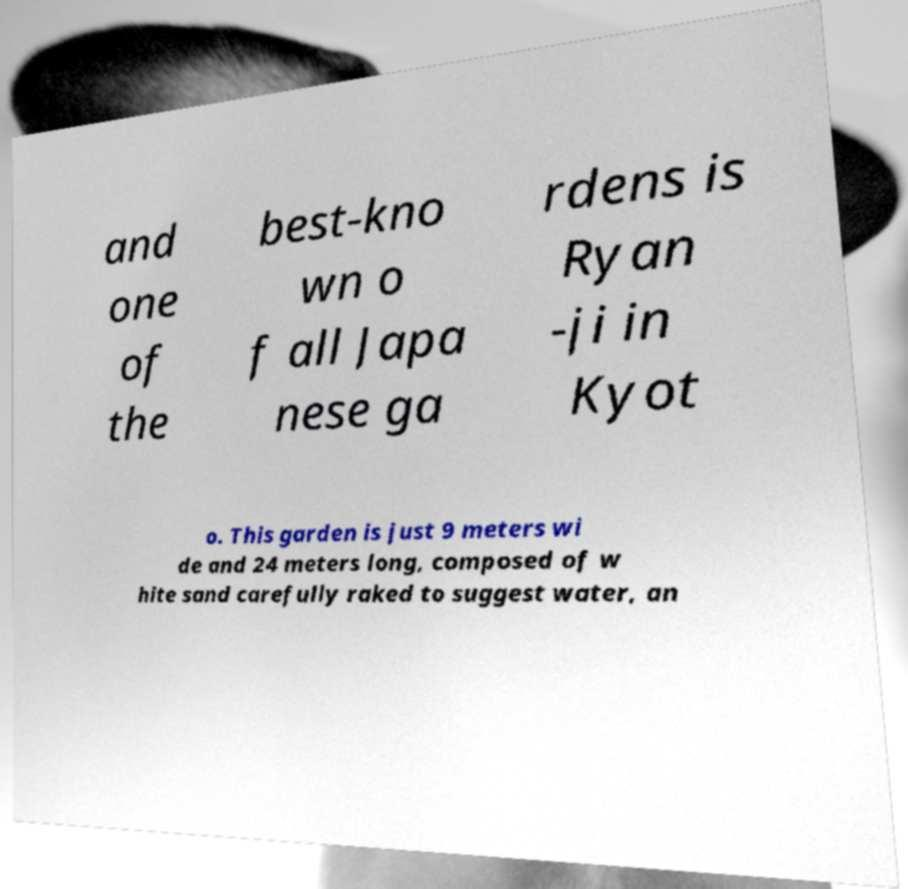For documentation purposes, I need the text within this image transcribed. Could you provide that? and one of the best-kno wn o f all Japa nese ga rdens is Ryan -ji in Kyot o. This garden is just 9 meters wi de and 24 meters long, composed of w hite sand carefully raked to suggest water, an 